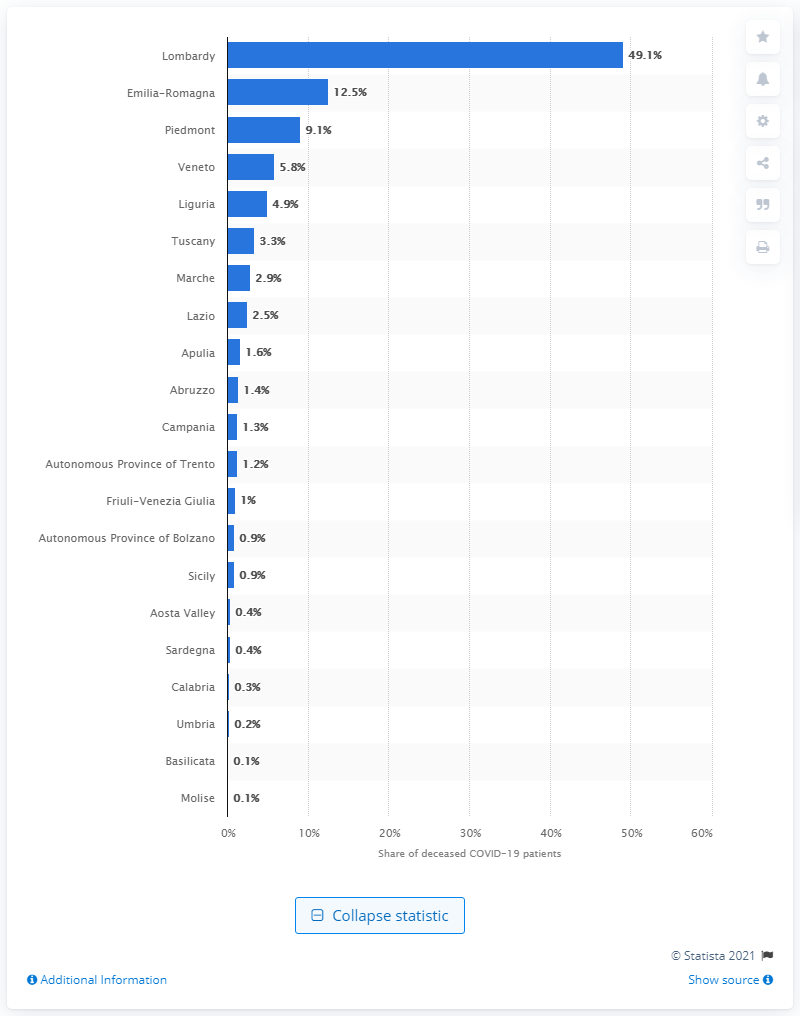Draw attention to some important aspects in this diagram. The epicenter of the coronavirus outbreak in Italy was located in the region of Lombardy. 